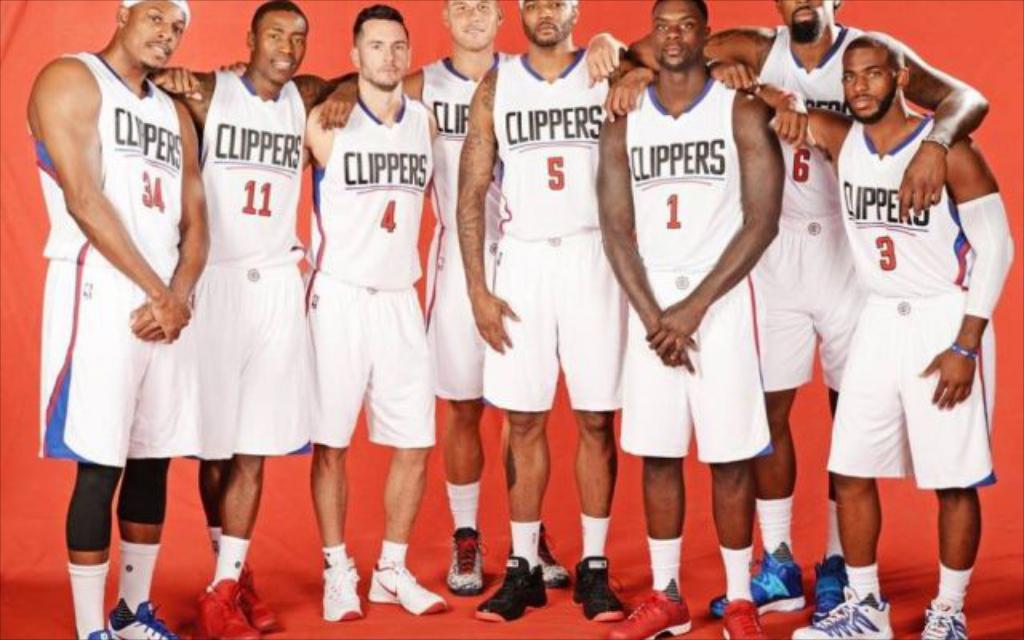<image>
Render a clear and concise summary of the photo. Members of the Clippers pose together for a team photograph. 